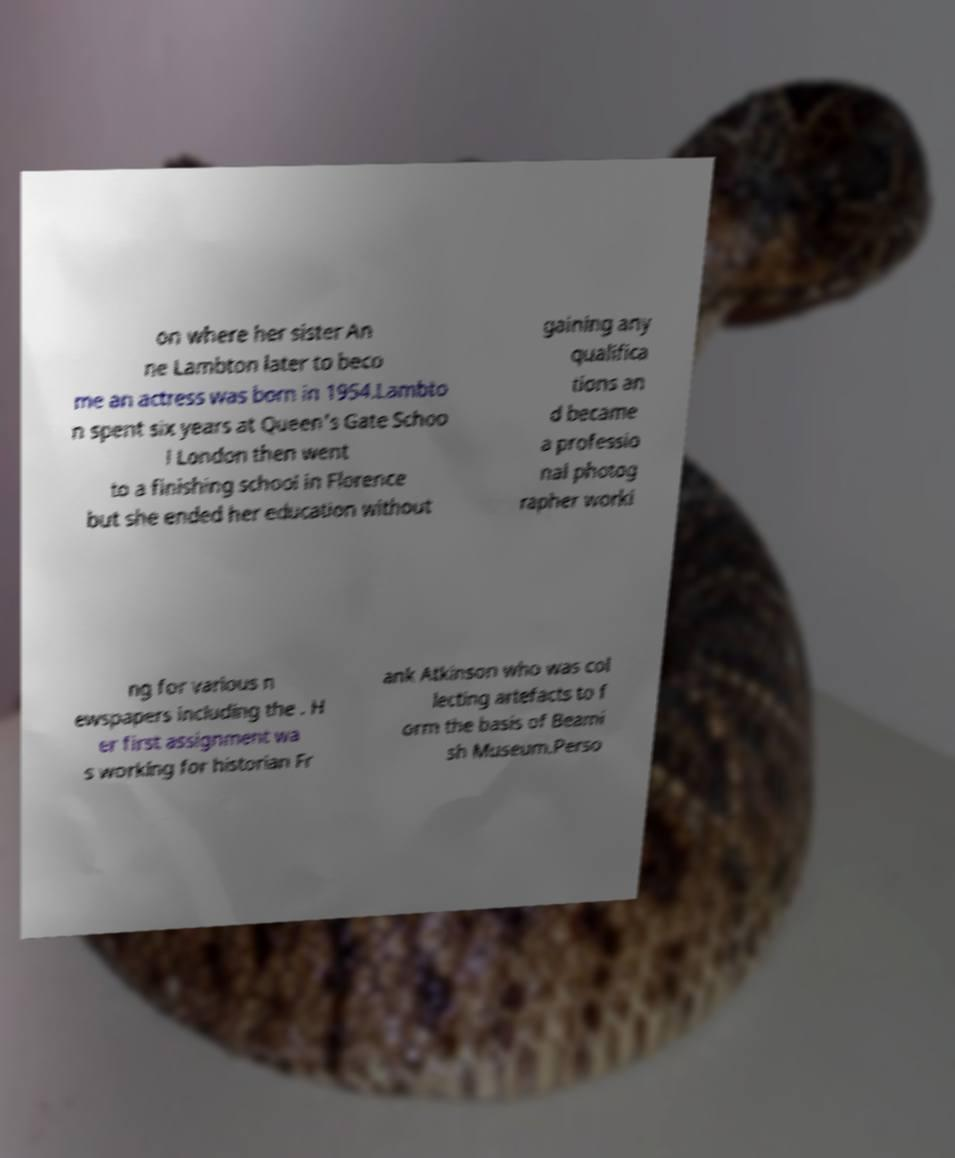Could you extract and type out the text from this image? on where her sister An ne Lambton later to beco me an actress was born in 1954.Lambto n spent six years at Queen's Gate Schoo l London then went to a finishing school in Florence but she ended her education without gaining any qualifica tions an d became a professio nal photog rapher worki ng for various n ewspapers including the . H er first assignment wa s working for historian Fr ank Atkinson who was col lecting artefacts to f orm the basis of Beami sh Museum.Perso 